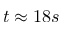Convert formula to latex. <formula><loc_0><loc_0><loc_500><loc_500>t \approx 1 8 s</formula> 